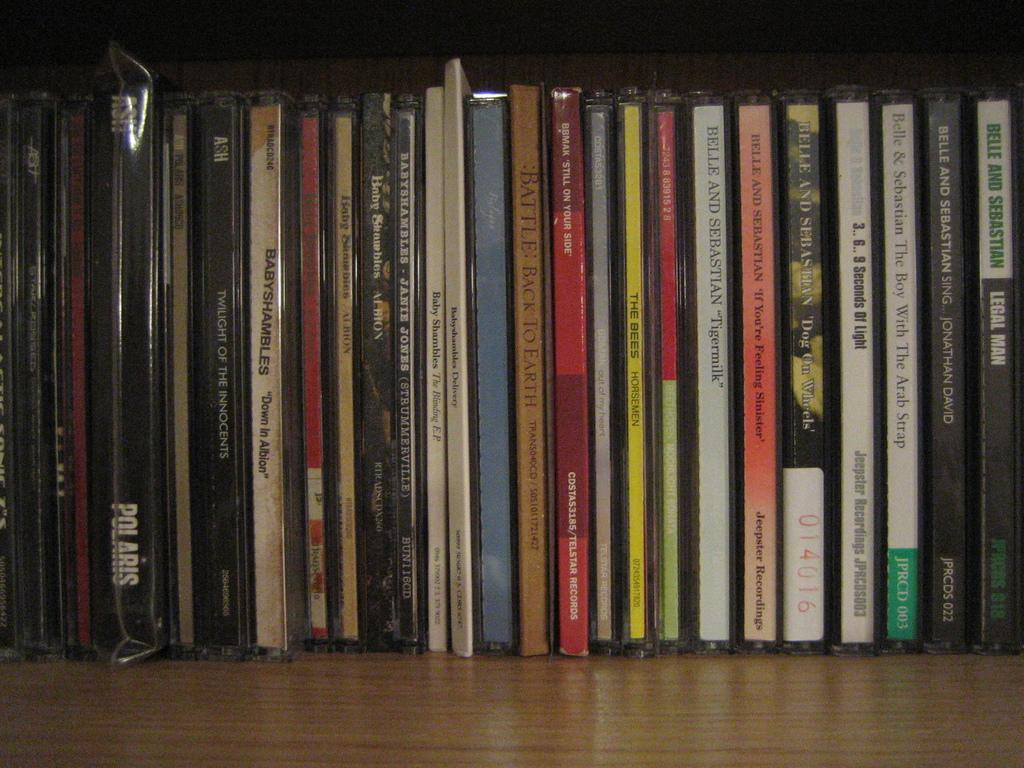<image>
Describe the image concisely. A persons alphabetized cd collection mostly consisting of Belle and Sebastian. 